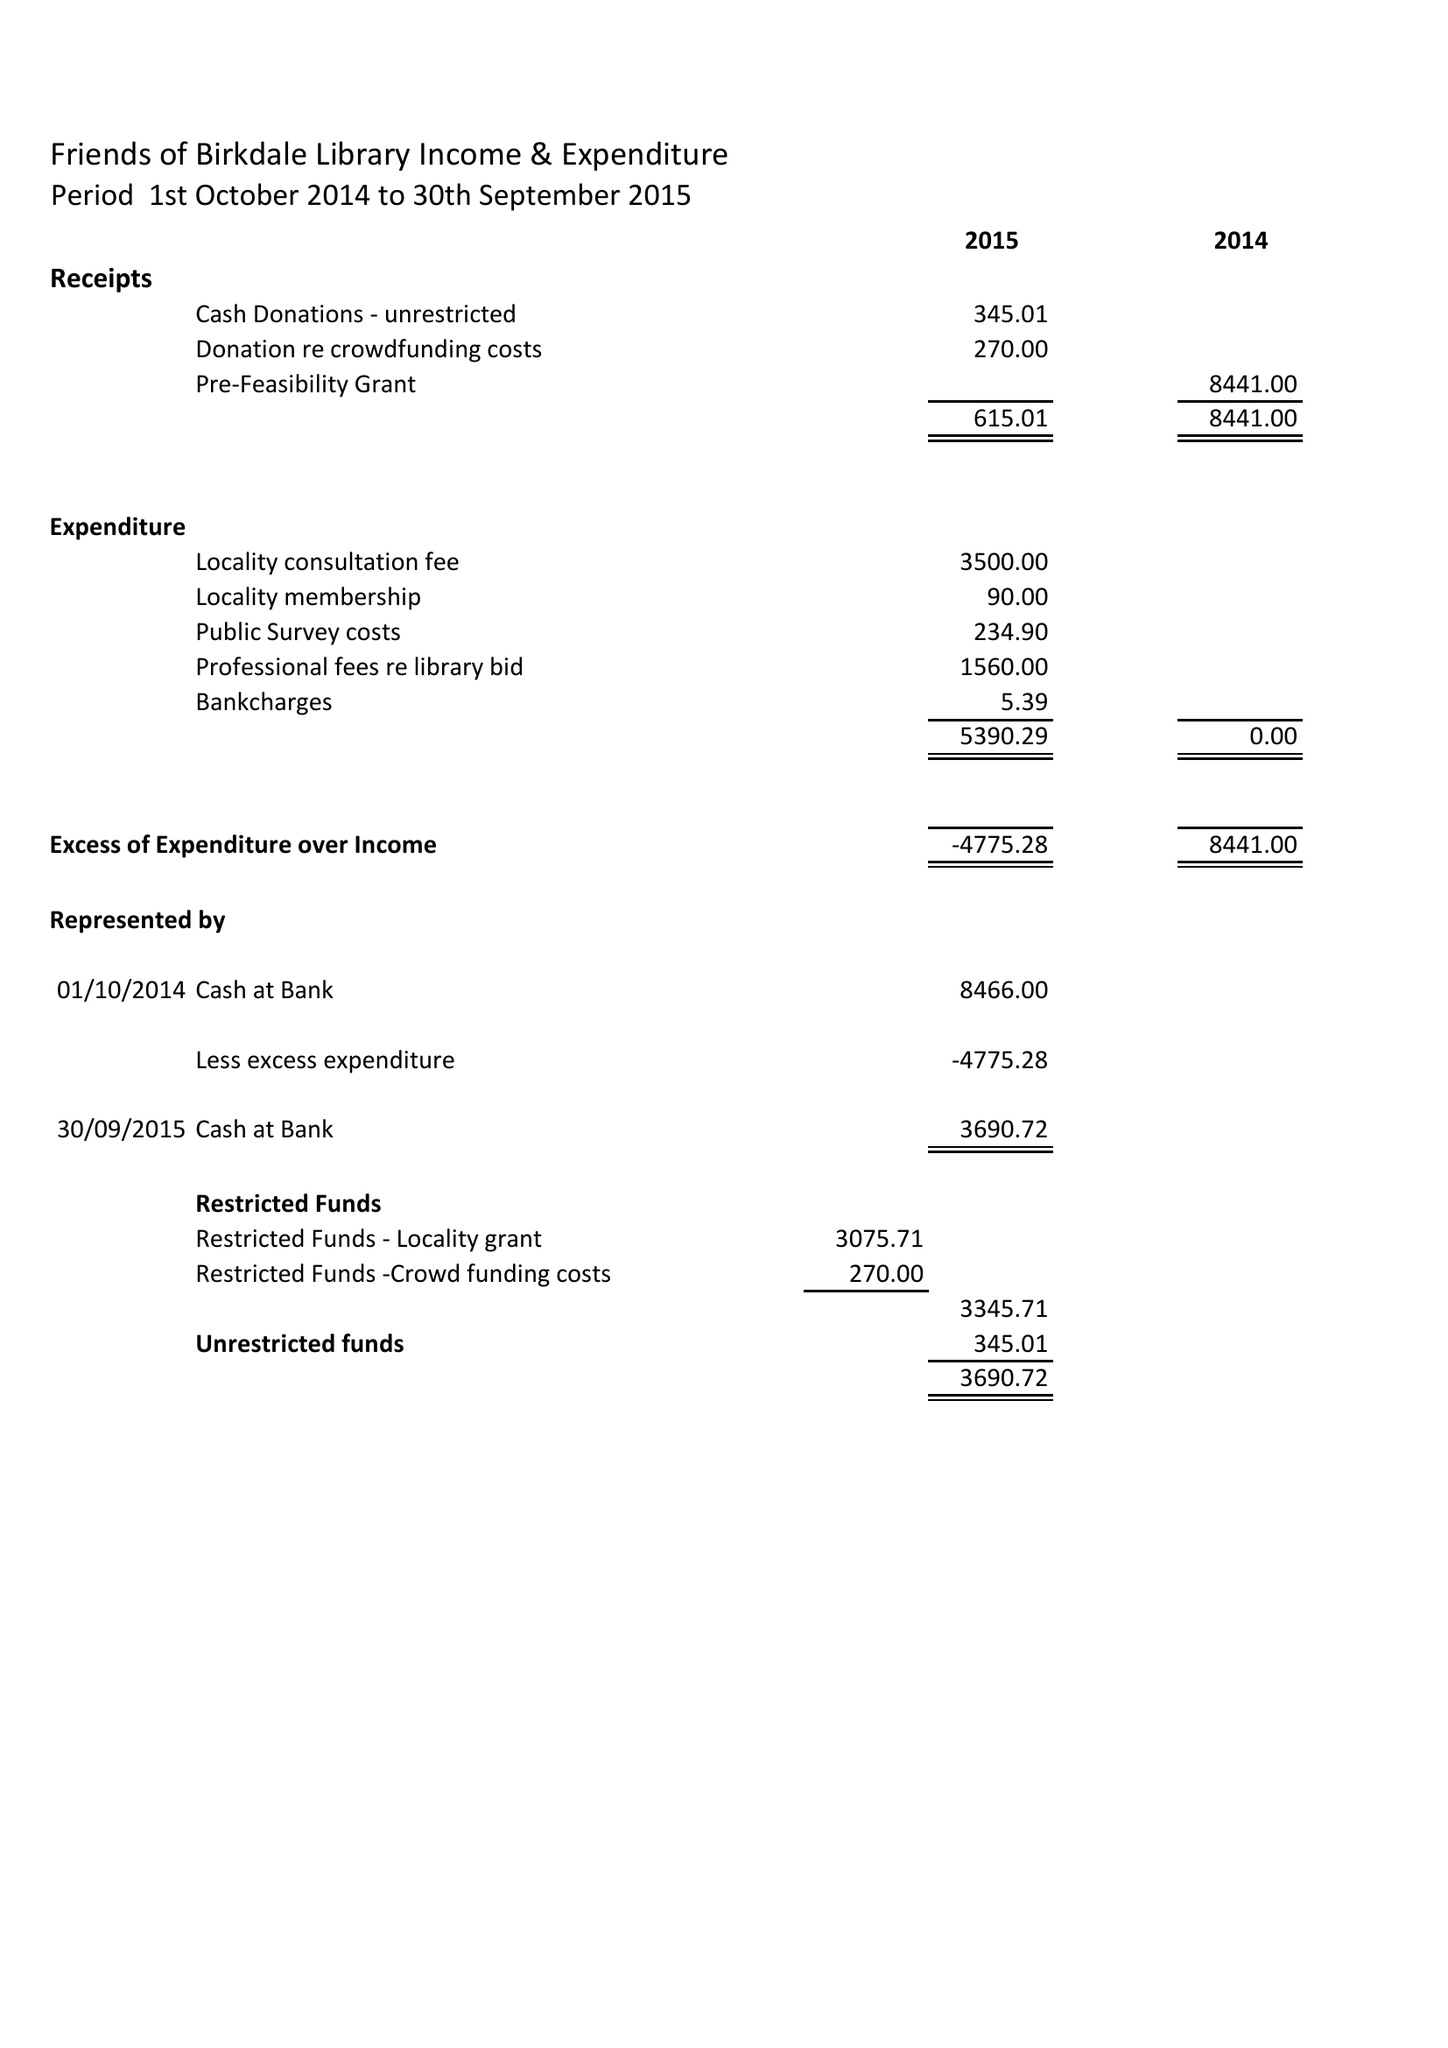What is the value for the charity_number?
Answer the question using a single word or phrase. 1153611 